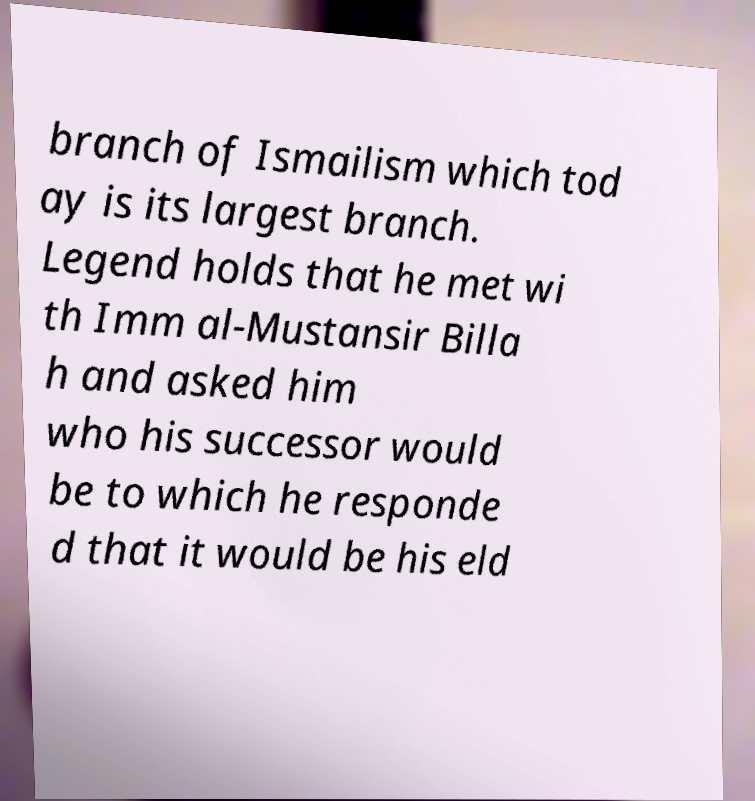I need the written content from this picture converted into text. Can you do that? branch of Ismailism which tod ay is its largest branch. Legend holds that he met wi th Imm al-Mustansir Billa h and asked him who his successor would be to which he responde d that it would be his eld 